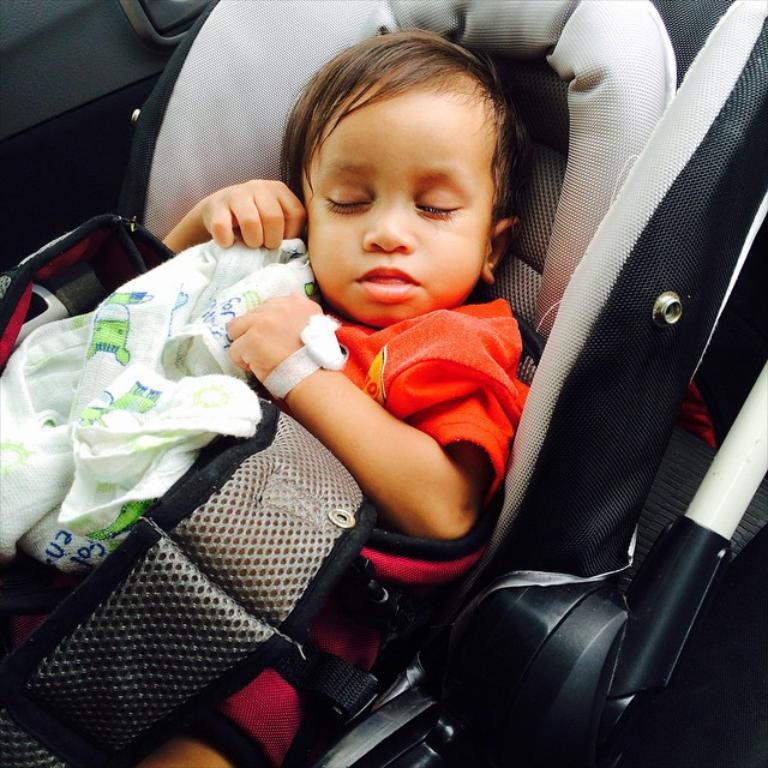What is the main subject of the image? The main subject of the image is a kid. What is the kid wearing in the image? The kid is wearing an orange dress in the image. What is the kid doing in the image? The kid is sleeping in a chair in the image. What is the kid holding in her hands? The kid is holding diapers in her hands in the image. What is the purpose of the sky in the image? The sky is not present in the image, so it does not have a purpose in this context. 